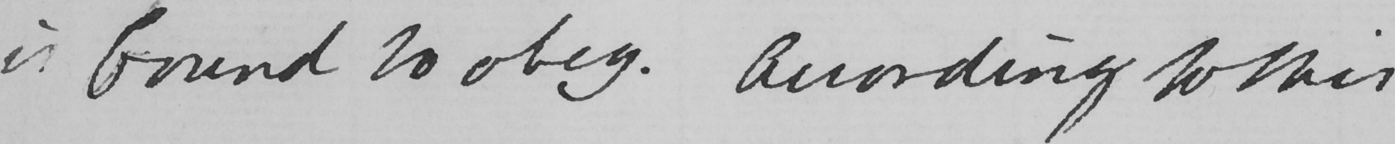What does this handwritten line say? is bound to obey . According to this 